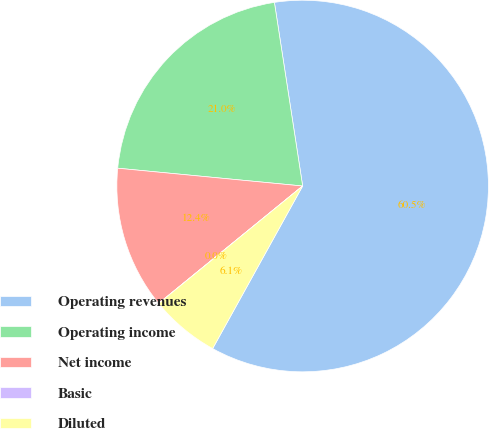Convert chart to OTSL. <chart><loc_0><loc_0><loc_500><loc_500><pie_chart><fcel>Operating revenues<fcel>Operating income<fcel>Net income<fcel>Basic<fcel>Diluted<nl><fcel>60.47%<fcel>21.04%<fcel>12.41%<fcel>0.01%<fcel>6.06%<nl></chart> 